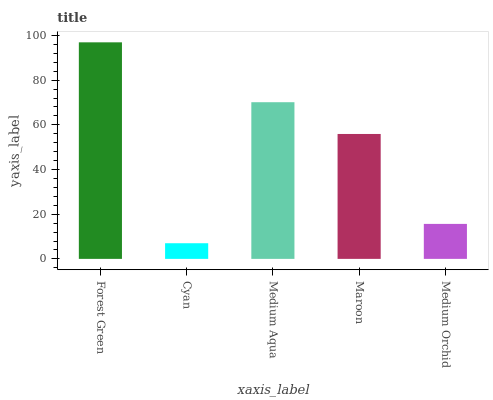Is Cyan the minimum?
Answer yes or no. Yes. Is Forest Green the maximum?
Answer yes or no. Yes. Is Medium Aqua the minimum?
Answer yes or no. No. Is Medium Aqua the maximum?
Answer yes or no. No. Is Medium Aqua greater than Cyan?
Answer yes or no. Yes. Is Cyan less than Medium Aqua?
Answer yes or no. Yes. Is Cyan greater than Medium Aqua?
Answer yes or no. No. Is Medium Aqua less than Cyan?
Answer yes or no. No. Is Maroon the high median?
Answer yes or no. Yes. Is Maroon the low median?
Answer yes or no. Yes. Is Forest Green the high median?
Answer yes or no. No. Is Forest Green the low median?
Answer yes or no. No. 